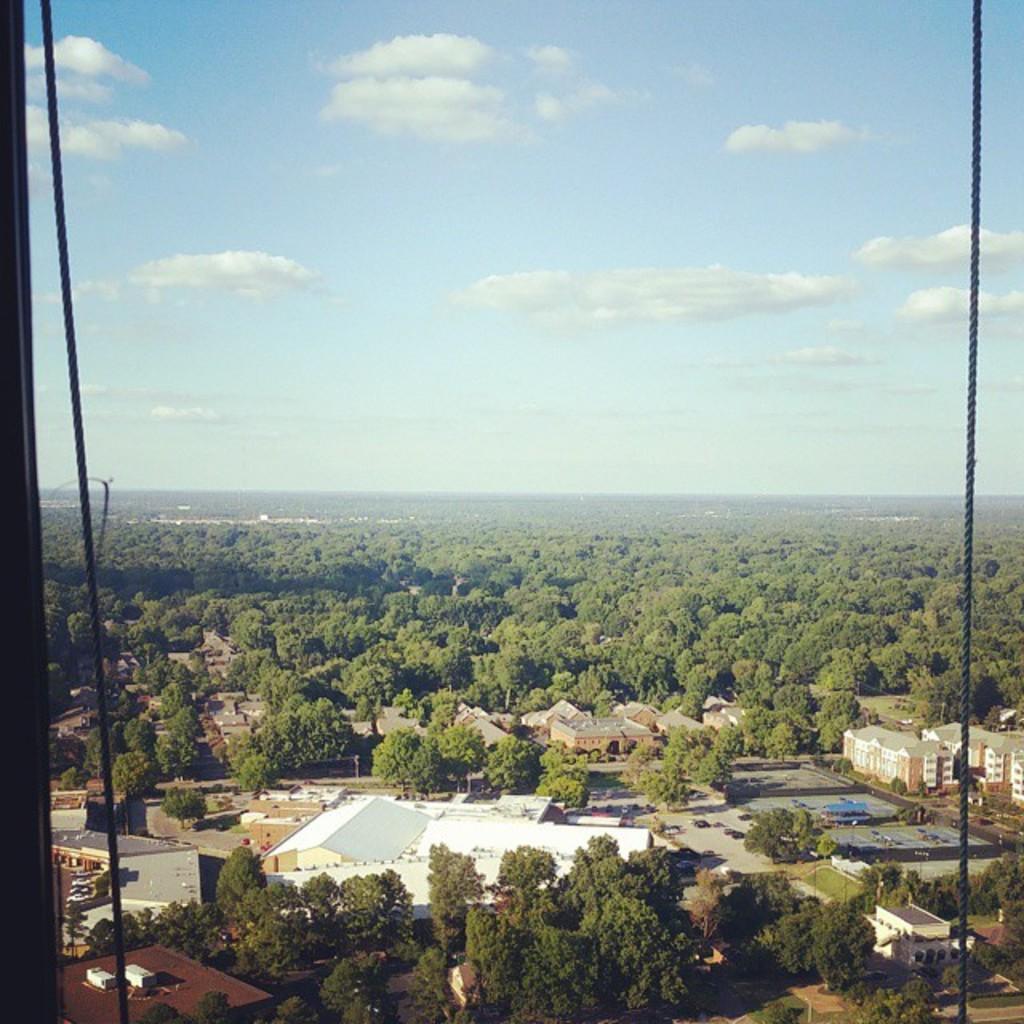Please provide a concise description of this image. In this picture we can see a few ropes, houses, trees, other objects and the clouds in the sky. 